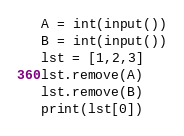<code> <loc_0><loc_0><loc_500><loc_500><_Python_>A = int(input())
B = int(input())
lst = [1,2,3]
lst.remove(A)
lst.remove(B)
print(lst[0])</code> 